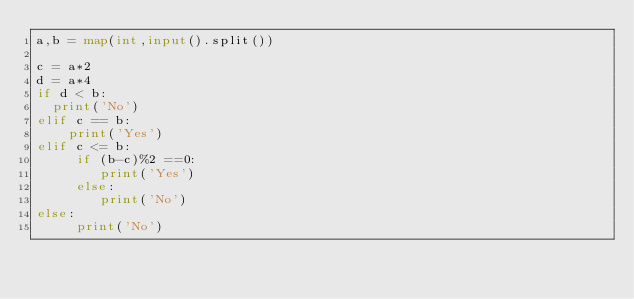Convert code to text. <code><loc_0><loc_0><loc_500><loc_500><_Python_>a,b = map(int,input().split())

c = a*2
d = a*4
if d < b:
  print('No')
elif c == b:
    print('Yes')
elif c <= b:
     if (b-c)%2 ==0:
        print('Yes')
     else:
        print('No')
else:
     print('No')</code> 